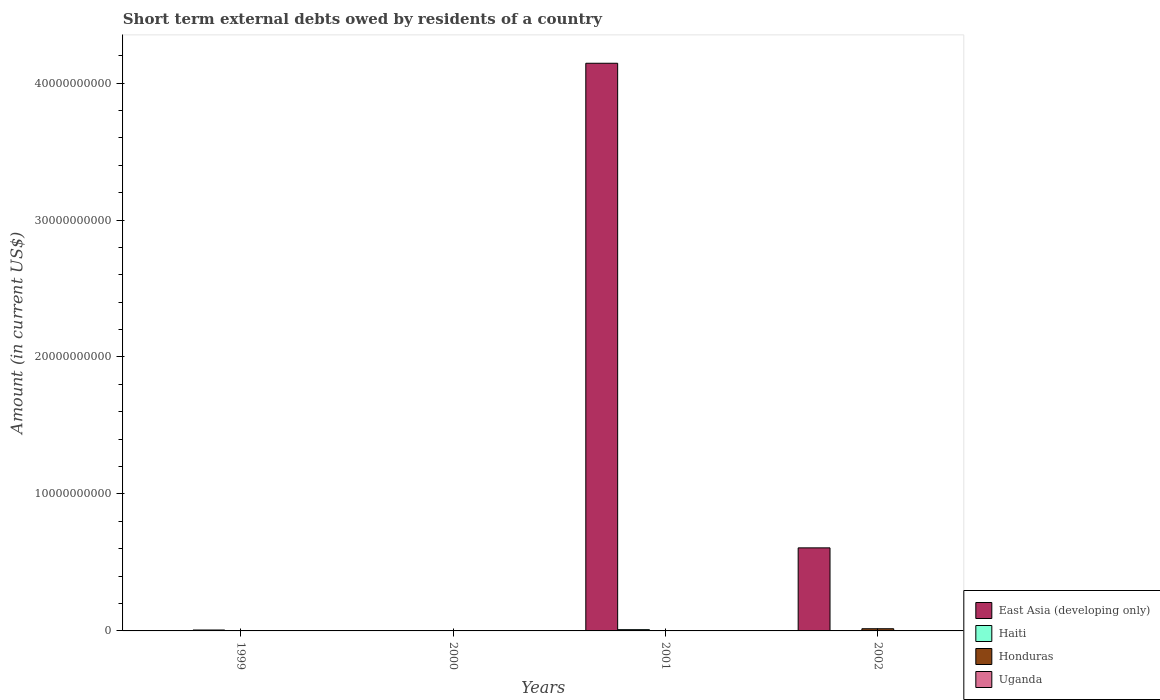Are the number of bars per tick equal to the number of legend labels?
Your answer should be compact. No. In how many cases, is the number of bars for a given year not equal to the number of legend labels?
Ensure brevity in your answer.  4. What is the amount of short-term external debts owed by residents in East Asia (developing only) in 2002?
Give a very brief answer. 6.06e+09. Across all years, what is the maximum amount of short-term external debts owed by residents in Haiti?
Your answer should be compact. 9.23e+07. Across all years, what is the minimum amount of short-term external debts owed by residents in Haiti?
Ensure brevity in your answer.  0. What is the total amount of short-term external debts owed by residents in Haiti in the graph?
Your answer should be compact. 1.58e+08. What is the difference between the amount of short-term external debts owed by residents in Haiti in 1999 and that in 2001?
Provide a succinct answer. -2.61e+07. What is the difference between the amount of short-term external debts owed by residents in Haiti in 2000 and the amount of short-term external debts owed by residents in Honduras in 2002?
Offer a very short reply. -1.59e+08. What is the average amount of short-term external debts owed by residents in Haiti per year?
Ensure brevity in your answer.  3.96e+07. In the year 1999, what is the difference between the amount of short-term external debts owed by residents in Uganda and amount of short-term external debts owed by residents in Haiti?
Provide a short and direct response. -6.01e+07. What is the ratio of the amount of short-term external debts owed by residents in Uganda in 1999 to that in 2002?
Your answer should be very brief. 0.55. Is the amount of short-term external debts owed by residents in Uganda in 2001 less than that in 2002?
Your answer should be compact. Yes. What is the difference between the highest and the second highest amount of short-term external debts owed by residents in Uganda?
Make the answer very short. 4.96e+06. What is the difference between the highest and the lowest amount of short-term external debts owed by residents in Haiti?
Ensure brevity in your answer.  9.23e+07. Is it the case that in every year, the sum of the amount of short-term external debts owed by residents in Haiti and amount of short-term external debts owed by residents in Uganda is greater than the amount of short-term external debts owed by residents in East Asia (developing only)?
Your answer should be compact. No. Are all the bars in the graph horizontal?
Make the answer very short. No. How many years are there in the graph?
Provide a succinct answer. 4. What is the difference between two consecutive major ticks on the Y-axis?
Provide a succinct answer. 1.00e+1. Does the graph contain grids?
Provide a succinct answer. No. What is the title of the graph?
Your answer should be very brief. Short term external debts owed by residents of a country. Does "Isle of Man" appear as one of the legend labels in the graph?
Provide a succinct answer. No. What is the Amount (in current US$) of Haiti in 1999?
Provide a short and direct response. 6.62e+07. What is the Amount (in current US$) in Uganda in 1999?
Provide a short and direct response. 6.13e+06. What is the Amount (in current US$) of East Asia (developing only) in 2000?
Offer a very short reply. 0. What is the Amount (in current US$) of Haiti in 2000?
Provide a succinct answer. 0. What is the Amount (in current US$) of East Asia (developing only) in 2001?
Provide a succinct answer. 4.14e+1. What is the Amount (in current US$) of Haiti in 2001?
Offer a terse response. 9.23e+07. What is the Amount (in current US$) of Uganda in 2001?
Ensure brevity in your answer.  1.24e+06. What is the Amount (in current US$) of East Asia (developing only) in 2002?
Provide a short and direct response. 6.06e+09. What is the Amount (in current US$) in Honduras in 2002?
Your answer should be compact. 1.59e+08. What is the Amount (in current US$) of Uganda in 2002?
Your answer should be compact. 1.11e+07. Across all years, what is the maximum Amount (in current US$) in East Asia (developing only)?
Make the answer very short. 4.14e+1. Across all years, what is the maximum Amount (in current US$) of Haiti?
Your response must be concise. 9.23e+07. Across all years, what is the maximum Amount (in current US$) in Honduras?
Provide a short and direct response. 1.59e+08. Across all years, what is the maximum Amount (in current US$) of Uganda?
Offer a terse response. 1.11e+07. Across all years, what is the minimum Amount (in current US$) of East Asia (developing only)?
Provide a short and direct response. 0. Across all years, what is the minimum Amount (in current US$) of Haiti?
Your answer should be compact. 0. Across all years, what is the minimum Amount (in current US$) in Uganda?
Your answer should be very brief. 0. What is the total Amount (in current US$) in East Asia (developing only) in the graph?
Make the answer very short. 4.75e+1. What is the total Amount (in current US$) in Haiti in the graph?
Your answer should be compact. 1.58e+08. What is the total Amount (in current US$) in Honduras in the graph?
Your answer should be compact. 1.59e+08. What is the total Amount (in current US$) of Uganda in the graph?
Offer a terse response. 1.85e+07. What is the difference between the Amount (in current US$) of Haiti in 1999 and that in 2001?
Offer a terse response. -2.61e+07. What is the difference between the Amount (in current US$) in Uganda in 1999 and that in 2001?
Give a very brief answer. 4.89e+06. What is the difference between the Amount (in current US$) in Uganda in 1999 and that in 2002?
Offer a terse response. -4.96e+06. What is the difference between the Amount (in current US$) in East Asia (developing only) in 2001 and that in 2002?
Provide a short and direct response. 3.54e+1. What is the difference between the Amount (in current US$) of Uganda in 2001 and that in 2002?
Your answer should be very brief. -9.85e+06. What is the difference between the Amount (in current US$) in Haiti in 1999 and the Amount (in current US$) in Uganda in 2001?
Provide a short and direct response. 6.50e+07. What is the difference between the Amount (in current US$) in Haiti in 1999 and the Amount (in current US$) in Honduras in 2002?
Your answer should be very brief. -9.32e+07. What is the difference between the Amount (in current US$) of Haiti in 1999 and the Amount (in current US$) of Uganda in 2002?
Make the answer very short. 5.51e+07. What is the difference between the Amount (in current US$) of East Asia (developing only) in 2001 and the Amount (in current US$) of Honduras in 2002?
Offer a very short reply. 4.13e+1. What is the difference between the Amount (in current US$) in East Asia (developing only) in 2001 and the Amount (in current US$) in Uganda in 2002?
Offer a terse response. 4.14e+1. What is the difference between the Amount (in current US$) of Haiti in 2001 and the Amount (in current US$) of Honduras in 2002?
Offer a terse response. -6.71e+07. What is the difference between the Amount (in current US$) in Haiti in 2001 and the Amount (in current US$) in Uganda in 2002?
Your response must be concise. 8.12e+07. What is the average Amount (in current US$) in East Asia (developing only) per year?
Offer a terse response. 1.19e+1. What is the average Amount (in current US$) in Haiti per year?
Your response must be concise. 3.96e+07. What is the average Amount (in current US$) in Honduras per year?
Make the answer very short. 3.98e+07. What is the average Amount (in current US$) in Uganda per year?
Provide a short and direct response. 4.62e+06. In the year 1999, what is the difference between the Amount (in current US$) of Haiti and Amount (in current US$) of Uganda?
Offer a terse response. 6.01e+07. In the year 2001, what is the difference between the Amount (in current US$) of East Asia (developing only) and Amount (in current US$) of Haiti?
Provide a succinct answer. 4.14e+1. In the year 2001, what is the difference between the Amount (in current US$) in East Asia (developing only) and Amount (in current US$) in Uganda?
Provide a short and direct response. 4.14e+1. In the year 2001, what is the difference between the Amount (in current US$) in Haiti and Amount (in current US$) in Uganda?
Make the answer very short. 9.10e+07. In the year 2002, what is the difference between the Amount (in current US$) in East Asia (developing only) and Amount (in current US$) in Honduras?
Give a very brief answer. 5.90e+09. In the year 2002, what is the difference between the Amount (in current US$) in East Asia (developing only) and Amount (in current US$) in Uganda?
Your answer should be very brief. 6.05e+09. In the year 2002, what is the difference between the Amount (in current US$) in Honduras and Amount (in current US$) in Uganda?
Your response must be concise. 1.48e+08. What is the ratio of the Amount (in current US$) in Haiti in 1999 to that in 2001?
Ensure brevity in your answer.  0.72. What is the ratio of the Amount (in current US$) of Uganda in 1999 to that in 2001?
Your response must be concise. 4.94. What is the ratio of the Amount (in current US$) in Uganda in 1999 to that in 2002?
Ensure brevity in your answer.  0.55. What is the ratio of the Amount (in current US$) of East Asia (developing only) in 2001 to that in 2002?
Provide a short and direct response. 6.84. What is the ratio of the Amount (in current US$) in Uganda in 2001 to that in 2002?
Offer a terse response. 0.11. What is the difference between the highest and the second highest Amount (in current US$) of Uganda?
Ensure brevity in your answer.  4.96e+06. What is the difference between the highest and the lowest Amount (in current US$) in East Asia (developing only)?
Ensure brevity in your answer.  4.14e+1. What is the difference between the highest and the lowest Amount (in current US$) in Haiti?
Keep it short and to the point. 9.23e+07. What is the difference between the highest and the lowest Amount (in current US$) in Honduras?
Provide a short and direct response. 1.59e+08. What is the difference between the highest and the lowest Amount (in current US$) in Uganda?
Keep it short and to the point. 1.11e+07. 